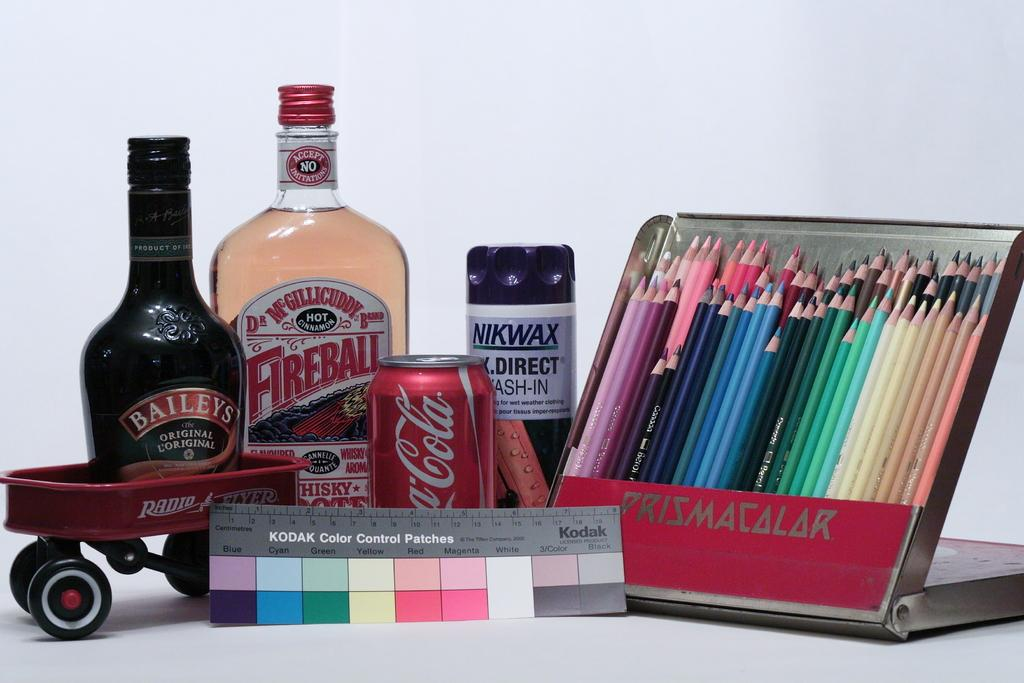What type of art supplies are visible in the image? There is a pencil color pencil set in the image. What can be used to determine the correct color for the pencils? There is a color chart with a scale in the image. What type of beverages might be consumed by the person using the pencils? There are drink bottles in the image. What type of small vehicle is present in the image? There is a small vehicle in the image. What type of bell can be heard ringing in the image? There is no bell present in the image, and therefore no sound can be heard. 